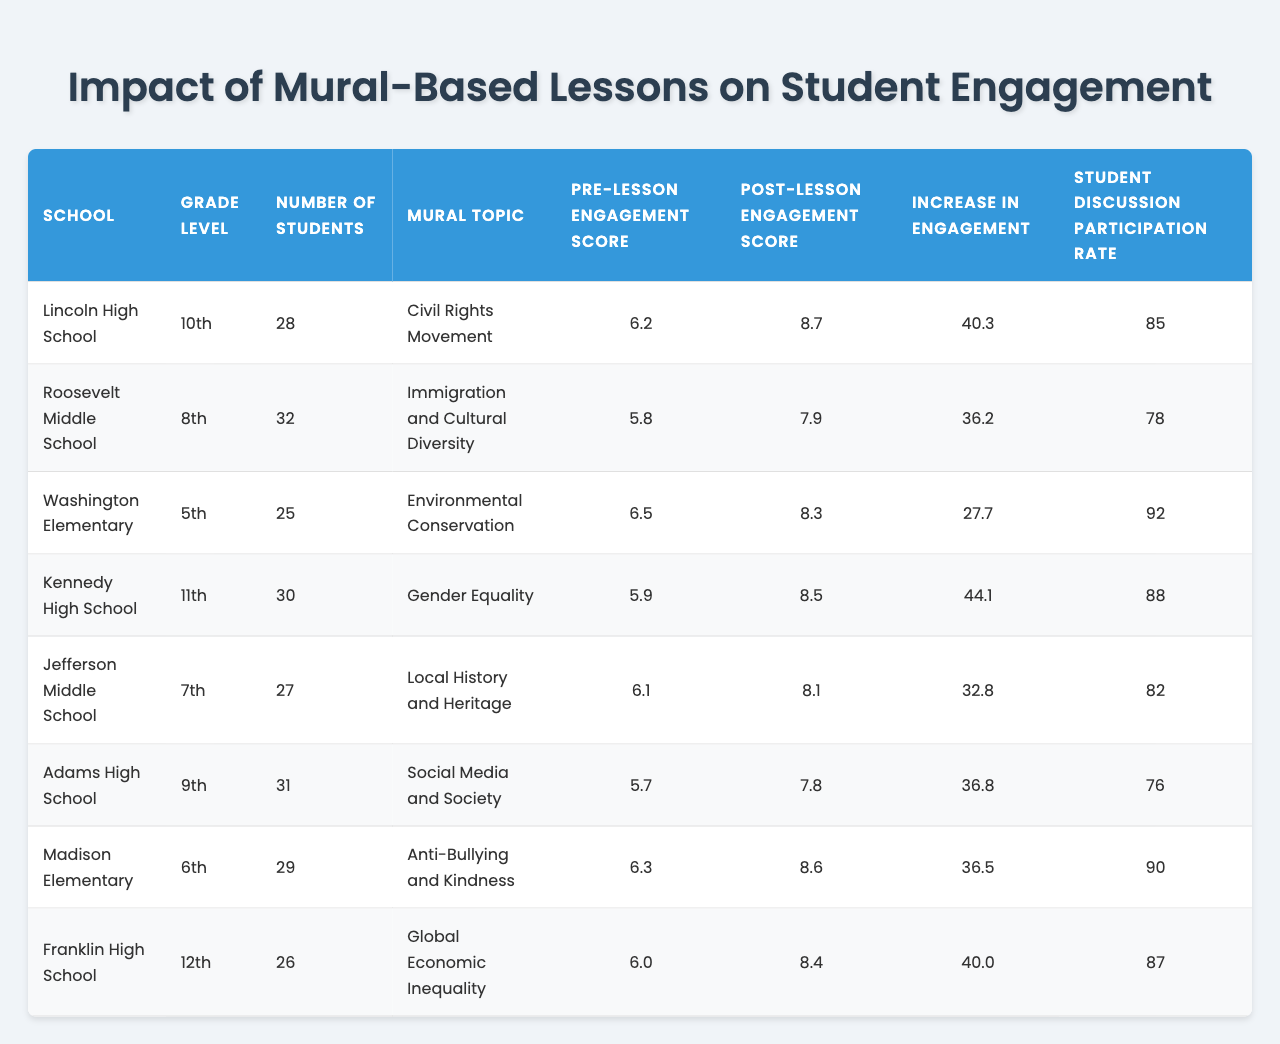What was the engagement score increase for students at Lincoln High School? The "Increase in Engagement" column shows that it was 40.3 for Lincoln High School.
Answer: 40.3 Which mural topic had the highest post-lesson engagement score? By looking at the "Post-lesson Engagement Score" column, Kennedy High School, with a score of 8.5 for the "Gender Equality" mural topic, has the highest score.
Answer: Gender Equality What is the total number of students across all schools? We sum the "Number of Students" values: 28 + 32 + 25 + 30 + 27 + 31 + 29 + 26 = 258, so the total is 258.
Answer: 258 Did Roosevelt Middle School have a higher pre-lesson or post-lesson engagement score? By checking the "Pre-lesson Engagement Score" of 5.8 and the "Post-lesson Engagement Score" of 7.9, we see the post-lesson score is higher.
Answer: Yes What is the average increase in engagement scores among all schools? We take the "Increase in Engagement" values: (40.3 + 36.2 + 27.7 + 44.1 + 32.8 + 36.8 + 36.5 + 40.0) = 294.4, and divide by 8 (the number of schools) to get an average of 36.8.
Answer: 36.8 Which grade level had the most students participating in mural-based lessons? Comparing the "Number of Students": 28 (10th), 32 (8th), 25 (5th), 30 (11th), 27 (7th), 31 (9th), 29 (6th), and 26 (12th), 32 (8th grade) has the most students.
Answer: 8th grade Is there a positive relationship between pre-lesson engagement scores and the increase in engagement scores? Examining the data, we notice that higher pre-lesson scores do not consistently yield higher increases, demonstrating a mixed relationship.
Answer: No What is the engagement score increase for students in 11th grade, compared to those in 5th grade? The 11th grade (Kennedy High School) had an increase of 44.1, while the 5th grade (Washington Elementary) had 27.7. Comparing these shows that 11th grade had a significantly higher increase.
Answer: Higher for 11th grade Which school had the highest student discussion participation rate? In the "Student Discussion Participation Rate" column, Washington Elementary had the highest rate of 92.
Answer: Washington Elementary From all the schools, which one had the lowest pre-lesson engagement score? The "Pre-lesson Engagement Score" for Adams High School shows 5.7, which is the lowest among all listed.
Answer: Adams High School 